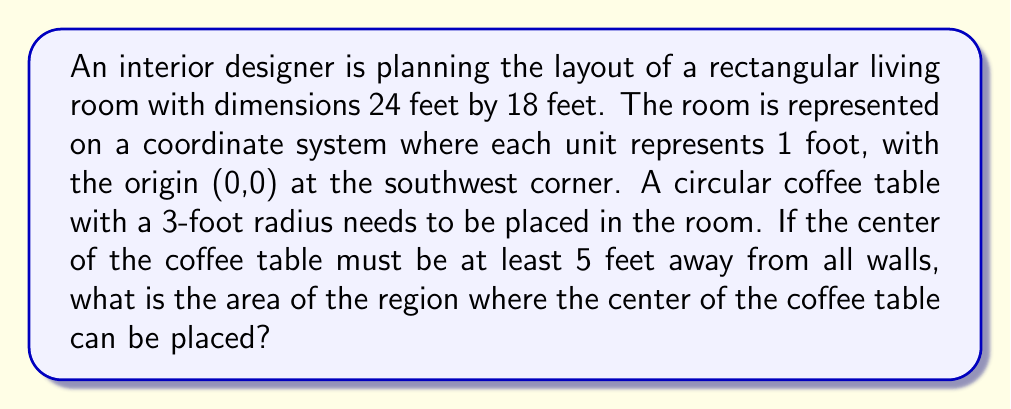Can you solve this math problem? Let's approach this step-by-step:

1) First, we need to determine the boundaries of the region where the center of the coffee table can be placed.

   - The room is 24 feet long (x-axis) and 18 feet wide (y-axis).
   - The center of the table must be at least 5 feet from all walls.

2) This means the x-coordinate of the center can range from 5 to 19, and the y-coordinate can range from 5 to 13.

3) We can represent this as a rectangle within the room:

   $$(x, y) \in [5, 19] \times [5, 13]$$

4) To calculate the area of this region, we need to find its dimensions:

   - Length: $19 - 5 = 14$ feet
   - Width: $13 - 5 = 8$ feet

5) The area of a rectangle is given by length × width:

   $$A = 14 \times 8 = 112$$ square feet

Therefore, the center of the coffee table can be placed anywhere within a 112 square foot area in the center of the room.

[asy]
unitsize(10);
draw((0,0)--(24,0)--(24,18)--(0,18)--cycle);
draw((5,5)--(19,5)--(19,13)--(5,13)--cycle, red);
label("24 ft", (12,-0.5));
label("18 ft", (24.5,9));
label("14 ft", (12,4.5));
label("8 ft", (19.5,9));
[/asy]
Answer: 112 sq ft 